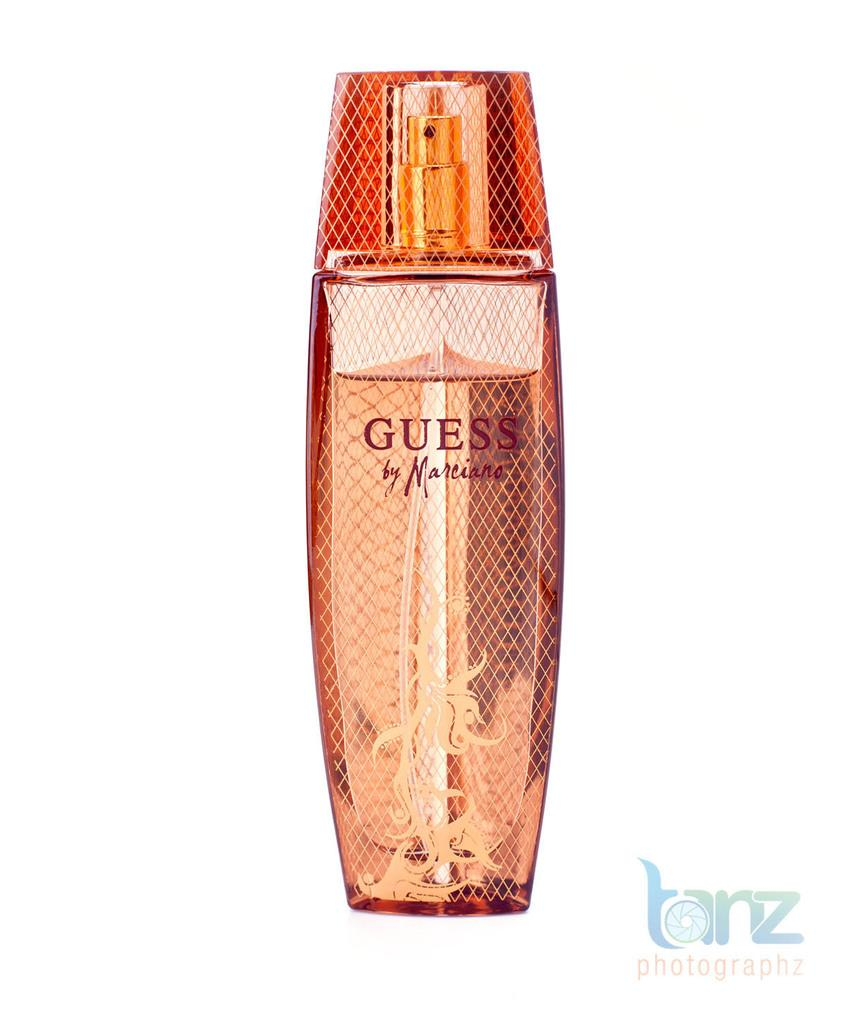<image>
Share a concise interpretation of the image provided. An orangish color bottle of Guess by Marciano, perfume. 